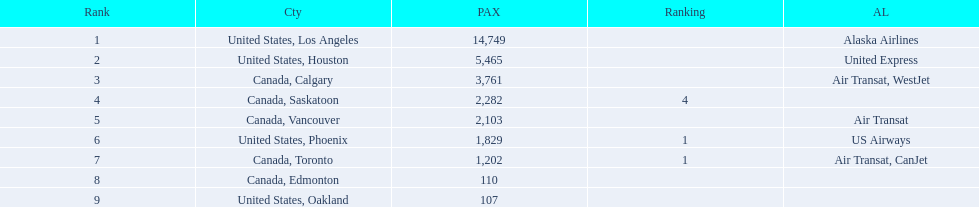What numbers are in the passengers column? 14,749, 5,465, 3,761, 2,282, 2,103, 1,829, 1,202, 110, 107. Parse the table in full. {'header': ['Rank', 'Cty', 'PAX', 'Ranking', 'AL'], 'rows': [['1', 'United States, Los Angeles', '14,749', '', 'Alaska Airlines'], ['2', 'United States, Houston', '5,465', '', 'United Express'], ['3', 'Canada, Calgary', '3,761', '', 'Air Transat, WestJet'], ['4', 'Canada, Saskatoon', '2,282', '4', ''], ['5', 'Canada, Vancouver', '2,103', '', 'Air Transat'], ['6', 'United States, Phoenix', '1,829', '1', 'US Airways'], ['7', 'Canada, Toronto', '1,202', '1', 'Air Transat, CanJet'], ['8', 'Canada, Edmonton', '110', '', ''], ['9', 'United States, Oakland', '107', '', '']]} Which number is the lowest number in the passengers column? 107. What city is associated with this number? United States, Oakland. 